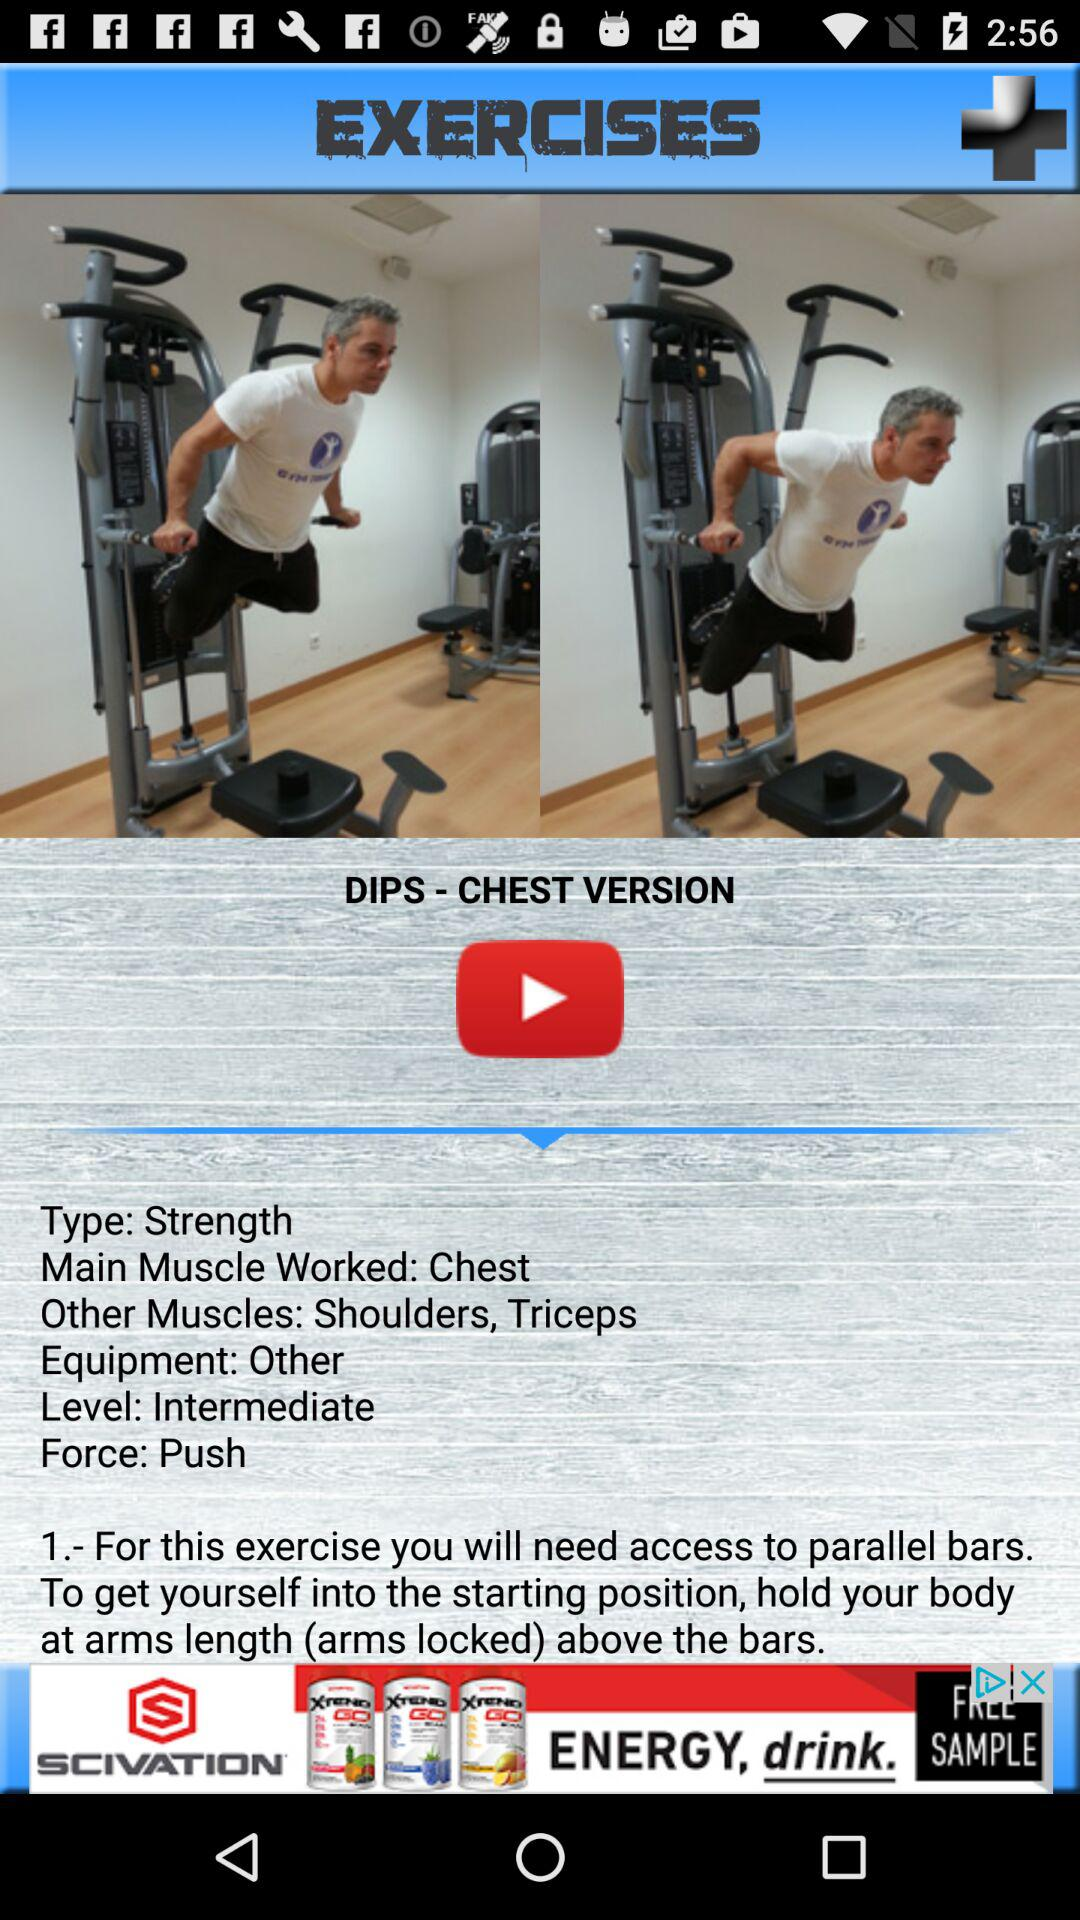What's the level of the chest exercise? The level of the chest exercise is intermediate. 